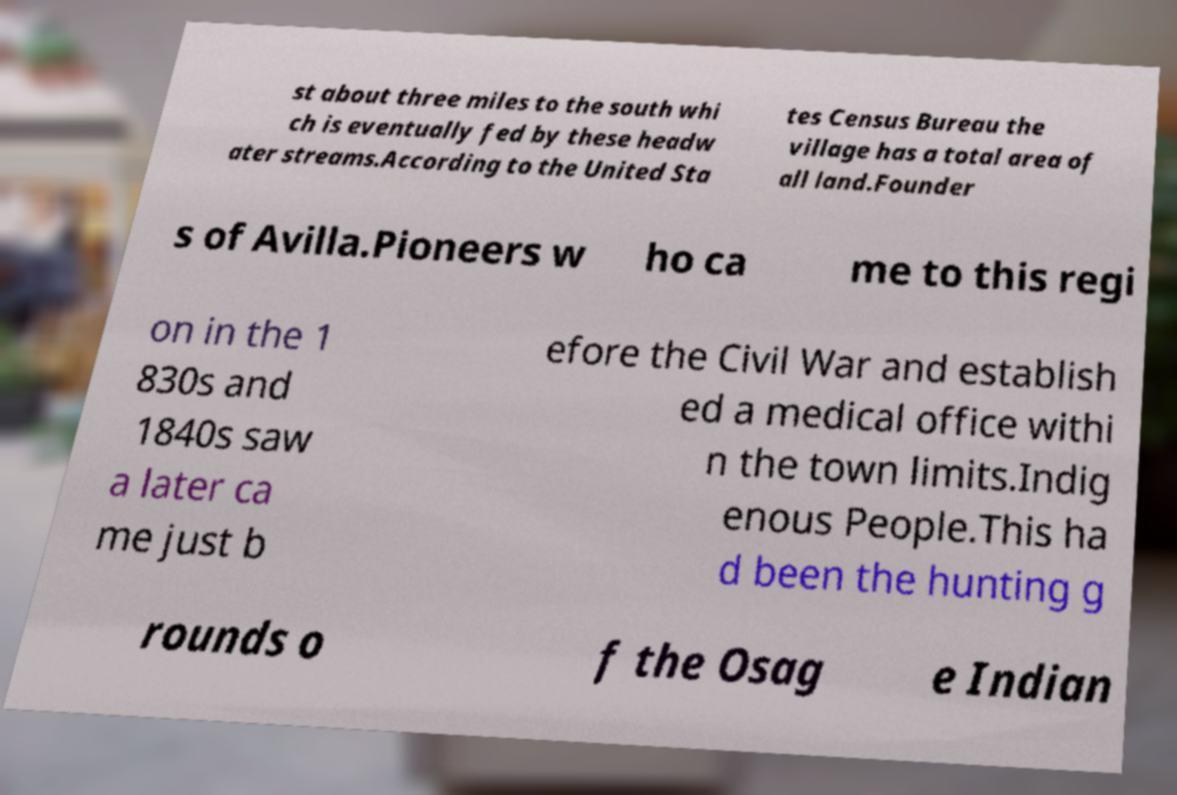Can you read and provide the text displayed in the image?This photo seems to have some interesting text. Can you extract and type it out for me? st about three miles to the south whi ch is eventually fed by these headw ater streams.According to the United Sta tes Census Bureau the village has a total area of all land.Founder s of Avilla.Pioneers w ho ca me to this regi on in the 1 830s and 1840s saw a later ca me just b efore the Civil War and establish ed a medical office withi n the town limits.Indig enous People.This ha d been the hunting g rounds o f the Osag e Indian 